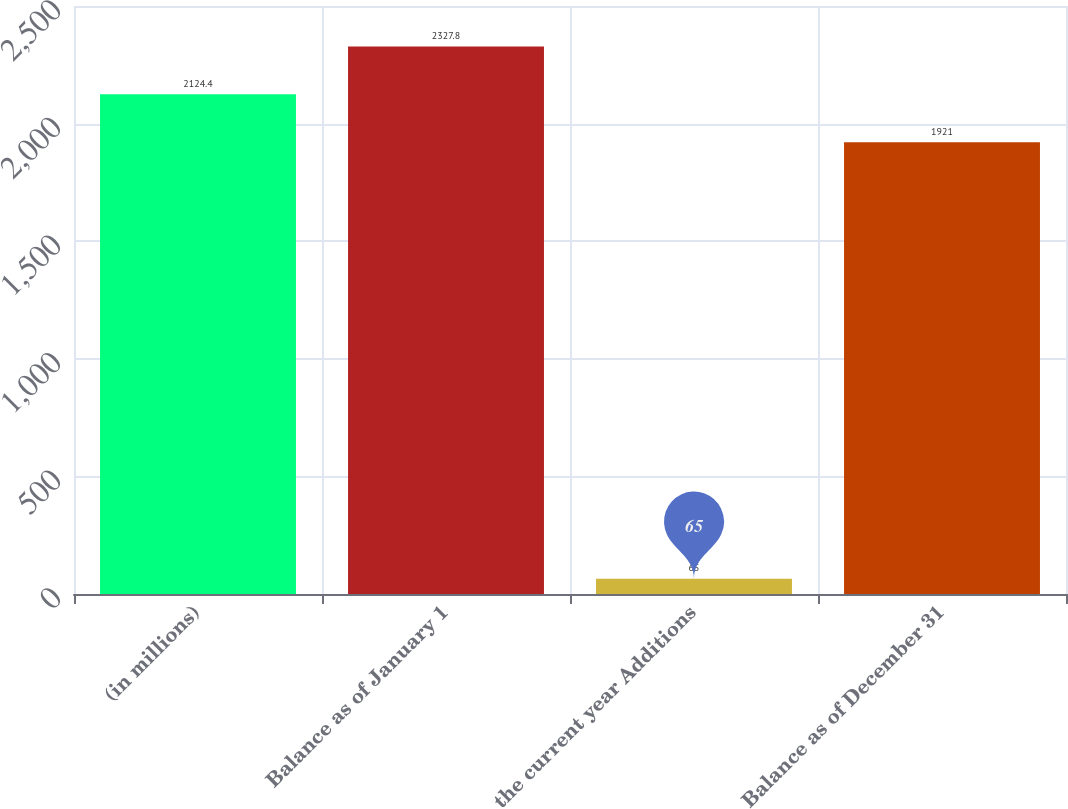Convert chart. <chart><loc_0><loc_0><loc_500><loc_500><bar_chart><fcel>(in millions)<fcel>Balance as of January 1<fcel>the current year Additions<fcel>Balance as of December 31<nl><fcel>2124.4<fcel>2327.8<fcel>65<fcel>1921<nl></chart> 